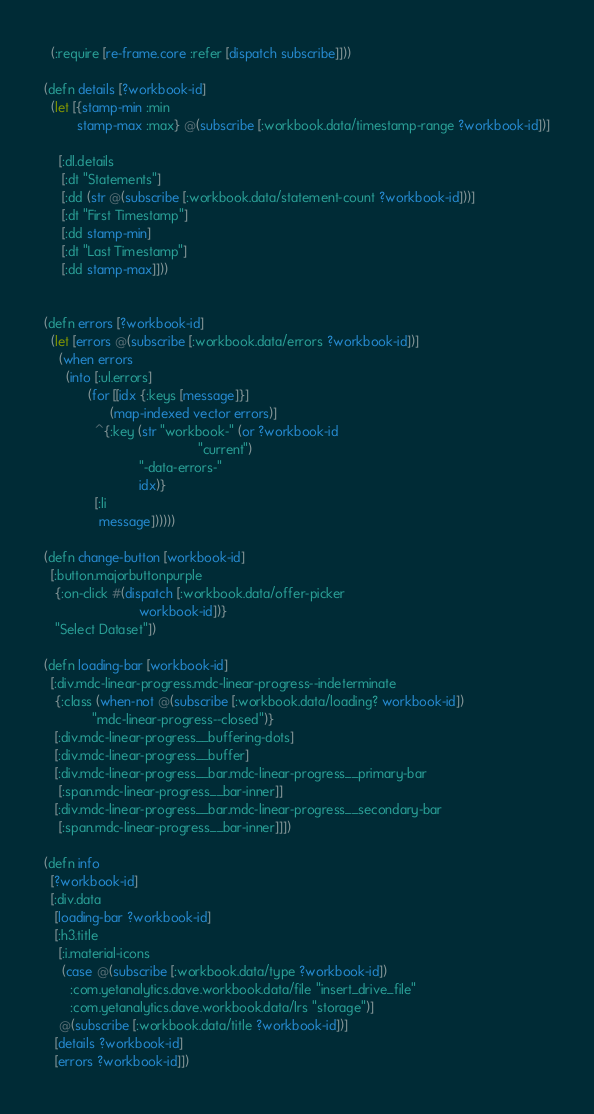<code> <loc_0><loc_0><loc_500><loc_500><_Clojure_>  (:require [re-frame.core :refer [dispatch subscribe]]))

(defn details [?workbook-id]
  (let [{stamp-min :min
         stamp-max :max} @(subscribe [:workbook.data/timestamp-range ?workbook-id])]

    [:dl.details
     [:dt "Statements"]
     [:dd (str @(subscribe [:workbook.data/statement-count ?workbook-id]))]
     [:dt "First Timestamp"]
     [:dd stamp-min]
     [:dt "Last Timestamp"]
     [:dd stamp-max]]))


(defn errors [?workbook-id]
  (let [errors @(subscribe [:workbook.data/errors ?workbook-id])]
    (when errors
      (into [:ul.errors]
            (for [[idx {:keys [message]}]
                  (map-indexed vector errors)]
              ^{:key (str "workbook-" (or ?workbook-id
                                          "current")
                          "-data-errors-"
                          idx)}
              [:li
               message])))))

(defn change-button [workbook-id]
  [:button.majorbuttonpurple
   {:on-click #(dispatch [:workbook.data/offer-picker
                          workbook-id])}
   "Select Dataset"])

(defn loading-bar [workbook-id]
  [:div.mdc-linear-progress.mdc-linear-progress--indeterminate
   {:class (when-not @(subscribe [:workbook.data/loading? workbook-id])
             "mdc-linear-progress--closed")}
   [:div.mdc-linear-progress__buffering-dots]
   [:div.mdc-linear-progress__buffer]
   [:div.mdc-linear-progress__bar.mdc-linear-progress__primary-bar
    [:span.mdc-linear-progress__bar-inner]]
   [:div.mdc-linear-progress__bar.mdc-linear-progress__secondary-bar
    [:span.mdc-linear-progress__bar-inner]]])

(defn info
  [?workbook-id]
  [:div.data
   [loading-bar ?workbook-id]
   [:h3.title
    [:i.material-icons
     (case @(subscribe [:workbook.data/type ?workbook-id])
       :com.yetanalytics.dave.workbook.data/file "insert_drive_file"
       :com.yetanalytics.dave.workbook.data/lrs "storage")]
    @(subscribe [:workbook.data/title ?workbook-id])]
   [details ?workbook-id]
   [errors ?workbook-id]])
</code> 